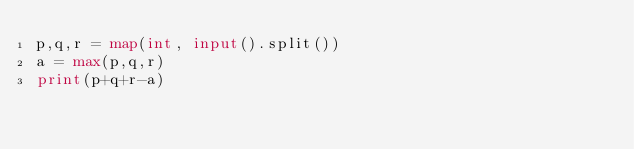Convert code to text. <code><loc_0><loc_0><loc_500><loc_500><_Python_>p,q,r = map(int, input().split())
a = max(p,q,r)
print(p+q+r-a)</code> 